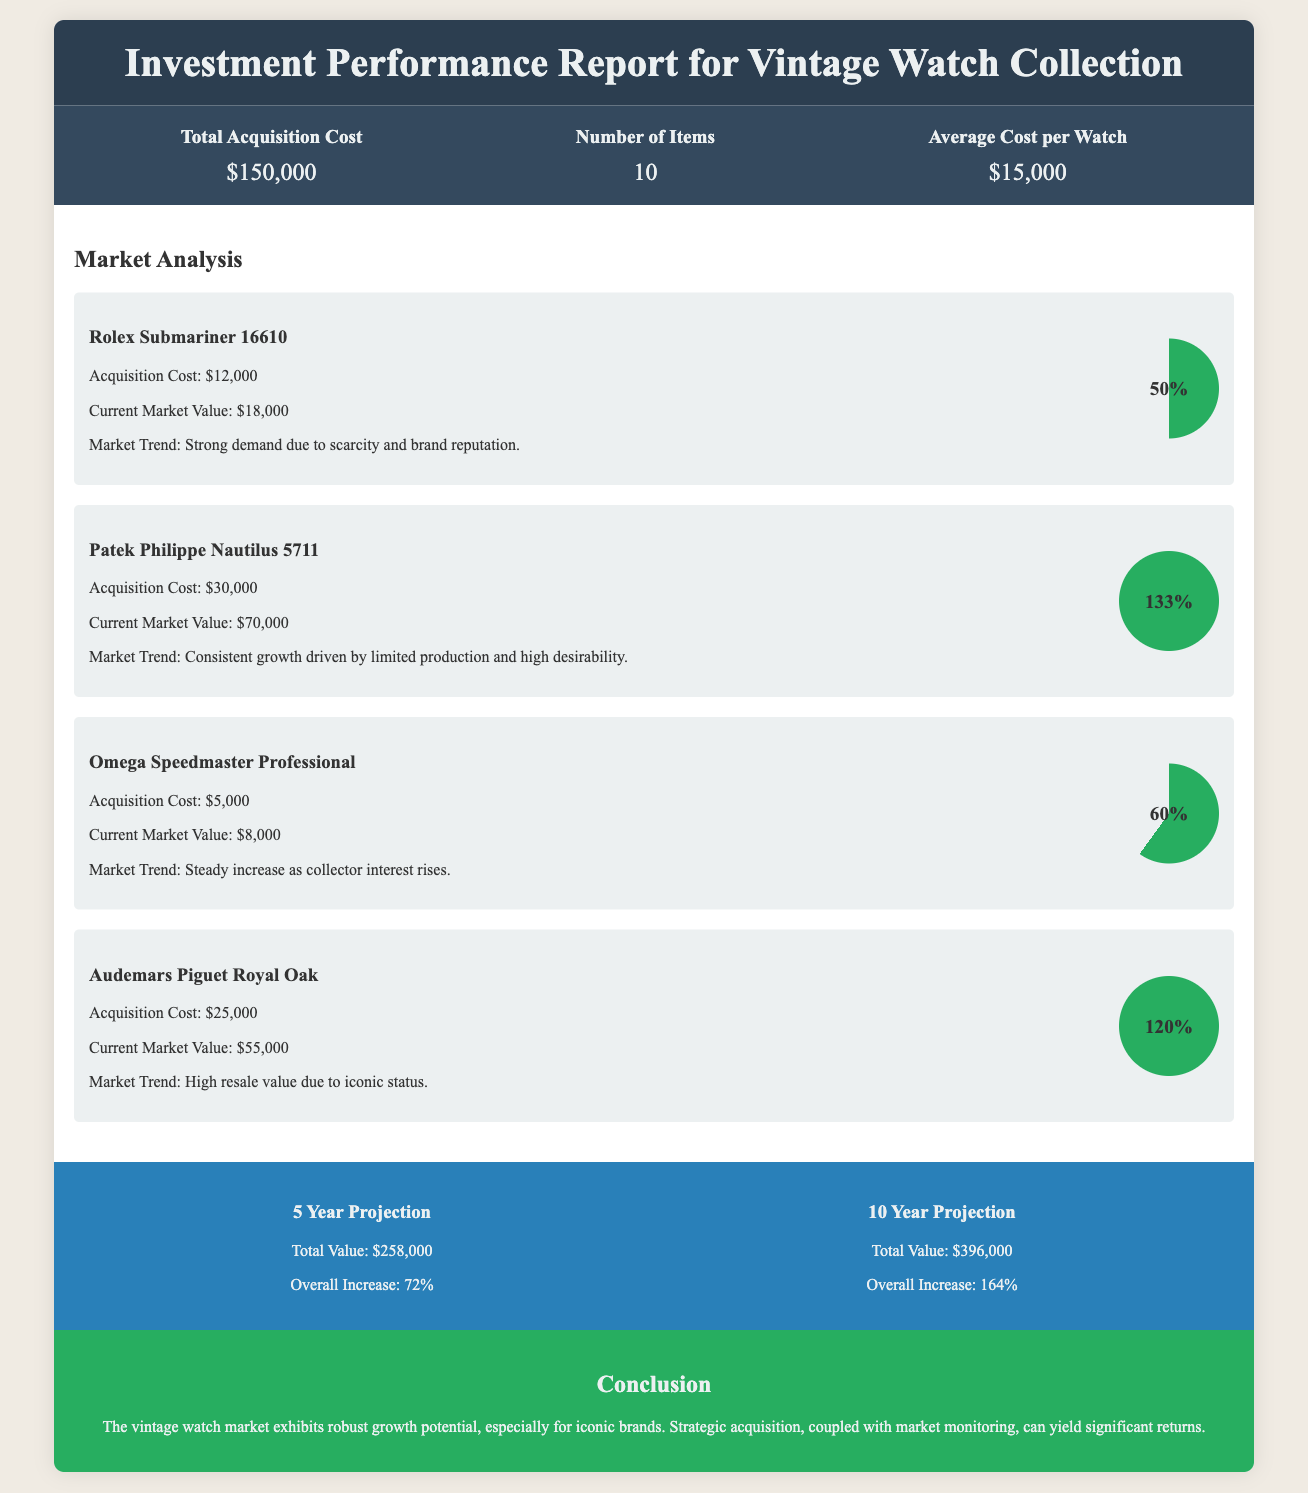What is the total acquisition cost? The total acquisition cost is provided in the overview section of the document.
Answer: $150,000 How many items are in the collection? The document explicitly states the number of items in the overview section.
Answer: 10 What is the average cost per watch? The average cost per watch is indicated in the overview section, calculated from the total acquisition cost and number of items.
Answer: $15,000 What is the current market value of the Rolex Submariner 16610? This information is provided under the market analysis section for each watch.
Answer: $18,000 Which watch has the highest current market value? By comparing the current market values listed in the market analysis, we find the watch with the highest value.
Answer: Patek Philippe Nautilus 5711 What is the overall increase projected over 10 years? The document provides this information in the projection section specifically for the 10-year projection.
Answer: 164% What is the market trend for the Omega Speedmaster Professional? The market trend is described for each watch in the market analysis section.
Answer: Steady increase as collector interest rises What is the total value projection for 5 years? This figure is found in the projections section of the document and represents the expected total value after 5 years.
Answer: $258,000 